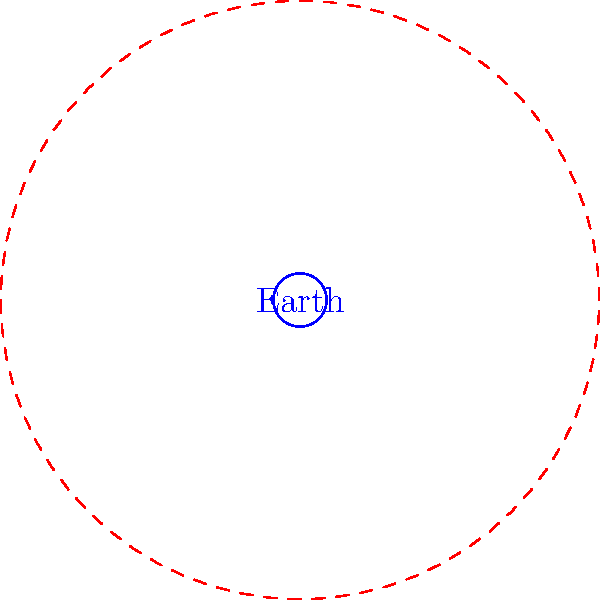In the cosmic arena of philosophical debate, where Earth's significance is but a speck in the grand scheme, how many times larger is Jupiter's diameter compared to Earth's? Ponder this while contemplating the futility of human existence. Let's approach this existential comparison step-by-step:

1) In the diagram, Earth is represented by the solid blue circle, while Jupiter is the dashed red circle.

2) The ratio of their diameters is equivalent to the ratio of their radii.

3) Jupiter's radius in the diagram is 11.2 units, while Earth's radius is 1 unit.

4) To find how many times larger Jupiter's diameter is, we calculate:

   $\frac{\text{Jupiter's diameter}}{\text{Earth's diameter}} = \frac{2 \times \text{Jupiter's radius}}{2 \times \text{Earth's radius}} = \frac{\text{Jupiter's radius}}{\text{Earth's radius}}$

5) Substituting the values:

   $\frac{11.2}{1} = 11.2$

6) Therefore, Jupiter's diameter is 11.2 times larger than Earth's.

This vast difference in size serves as a humbling reminder of our cosmic insignificance, much like the realization that our philosophical debates may ultimately be inconsequential in the face of the universe's indifference.
Answer: 11.2 times 